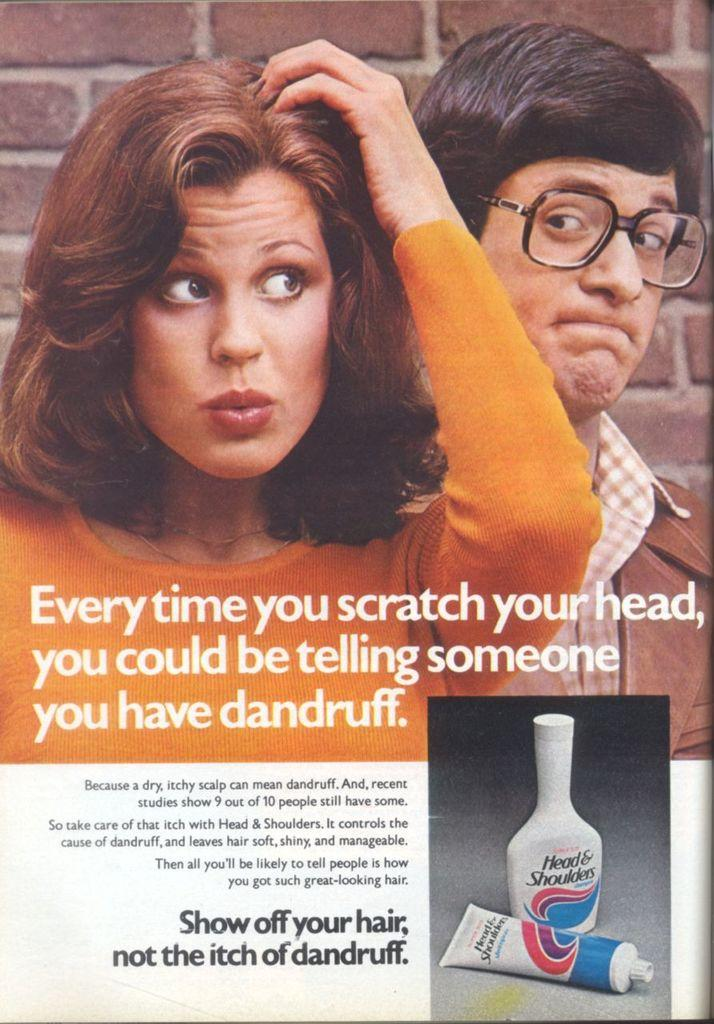<image>
Present a compact description of the photo's key features. a magazine that says to show off your hair 